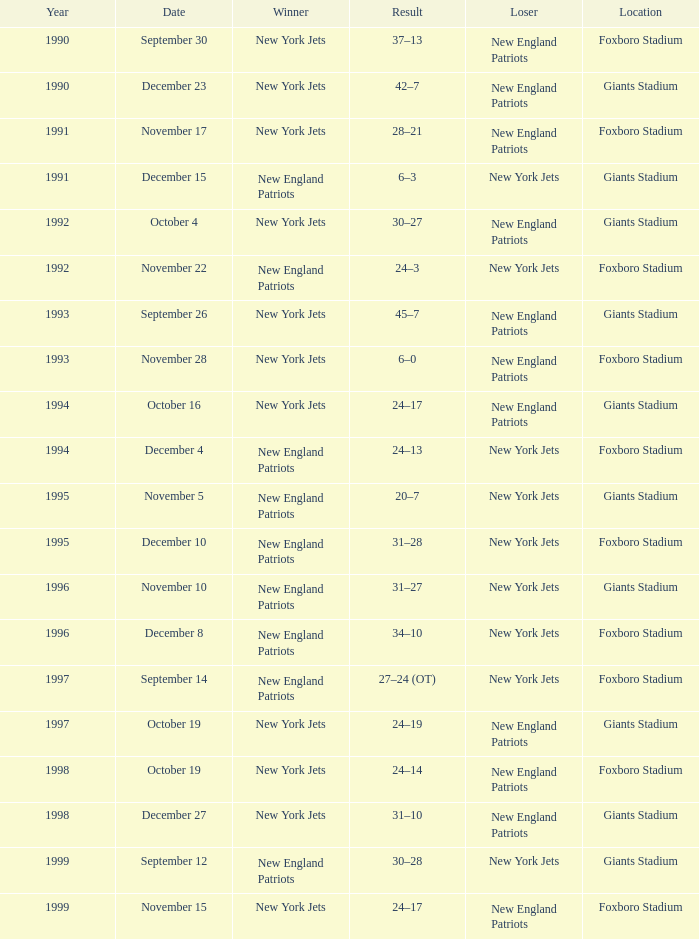What team was the lower when the winner was the new york jets, and a Year earlier than 1994, and a Result of 37–13? New England Patriots. 